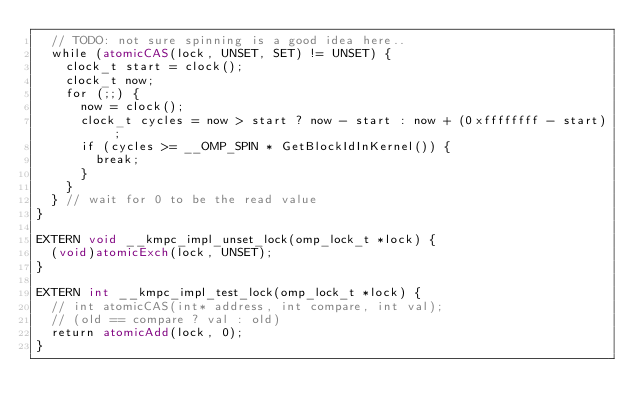Convert code to text. <code><loc_0><loc_0><loc_500><loc_500><_Cuda_>  // TODO: not sure spinning is a good idea here..
  while (atomicCAS(lock, UNSET, SET) != UNSET) {
    clock_t start = clock();
    clock_t now;
    for (;;) {
      now = clock();
      clock_t cycles = now > start ? now - start : now + (0xffffffff - start);
      if (cycles >= __OMP_SPIN * GetBlockIdInKernel()) {
        break;
      }
    }
  } // wait for 0 to be the read value
}

EXTERN void __kmpc_impl_unset_lock(omp_lock_t *lock) {
  (void)atomicExch(lock, UNSET);
}

EXTERN int __kmpc_impl_test_lock(omp_lock_t *lock) {
  // int atomicCAS(int* address, int compare, int val);
  // (old == compare ? val : old)
  return atomicAdd(lock, 0);
}
</code> 